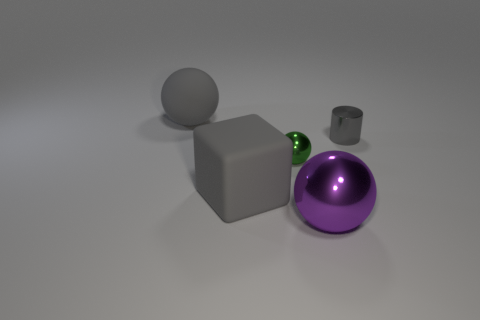Add 4 blue things. How many objects exist? 9 Subtract all cubes. How many objects are left? 4 Add 2 big matte balls. How many big matte balls are left? 3 Add 4 shiny objects. How many shiny objects exist? 7 Subtract 1 purple spheres. How many objects are left? 4 Subtract all large matte balls. Subtract all big gray balls. How many objects are left? 3 